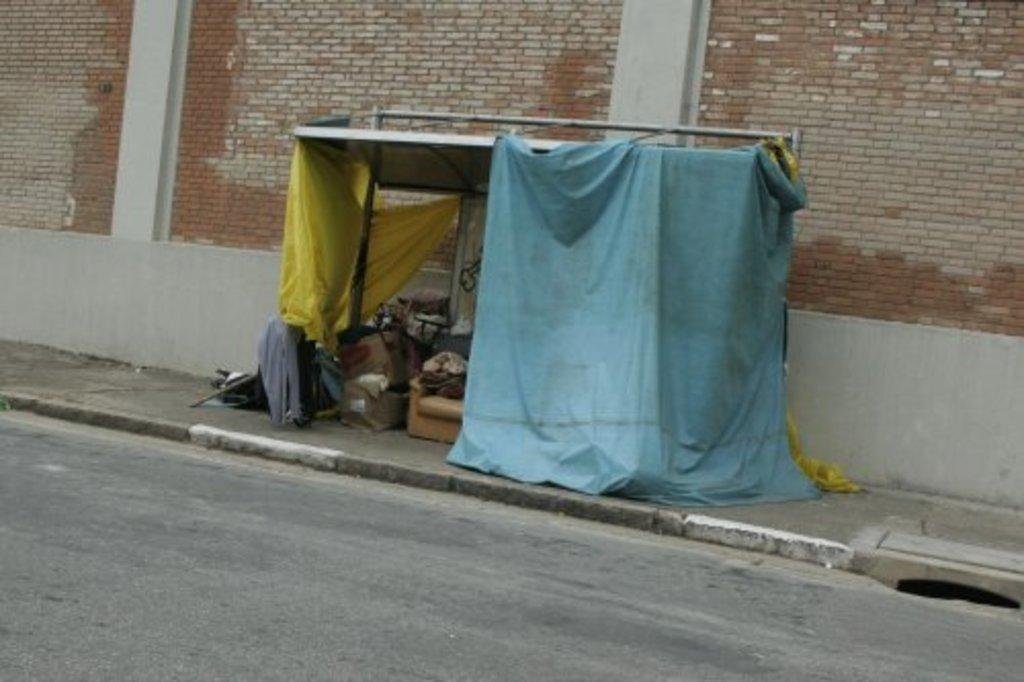What structure can be seen in the image? There is a shed in the image. What is inside the shed? There are things placed inside the shed. What is at the bottom of the image? There is a road at the bottom of the image. What can be seen in the background of the image? There is a wall in the background of the image. Can you see a library in the image? There is no library present in the image. Is there anyone jumping in the image? There is no one jumping in the image. 